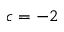<formula> <loc_0><loc_0><loc_500><loc_500>c = - 2</formula> 